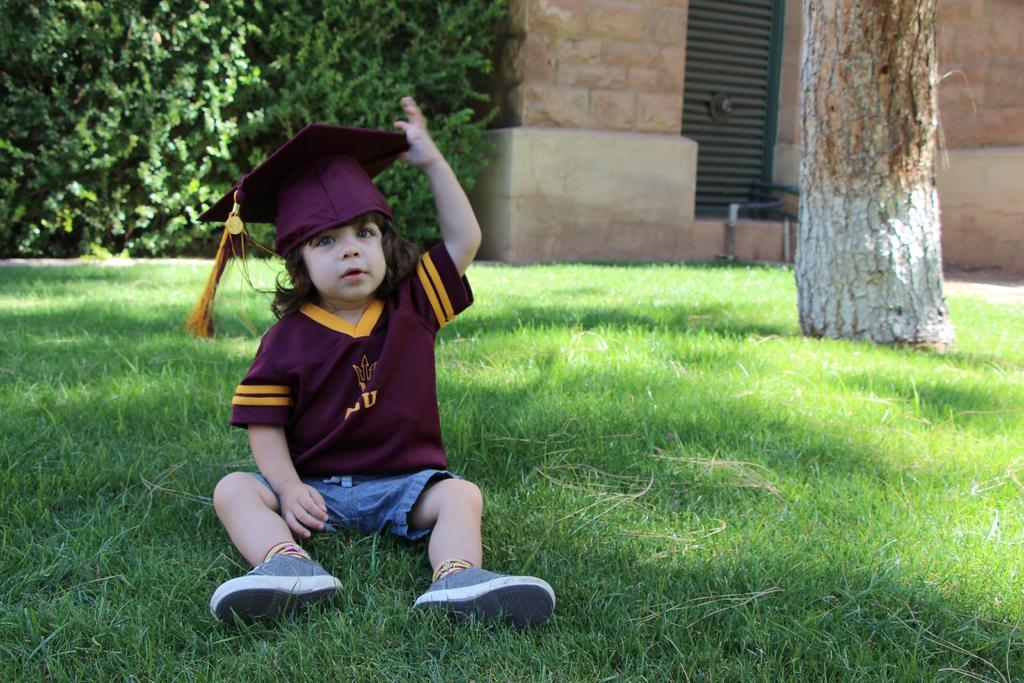Who is present in the image? There is a boy in the image. What is the boy wearing on his head? The boy is wearing a hat. What can be seen in the image besides the boy? There is a branch, grass, a wall, a grille, and plants visible in the image. How deep is the water in the image? There is no water present in the image. What type of volleyball is being played in the image? There is no volleyball present in the image. 